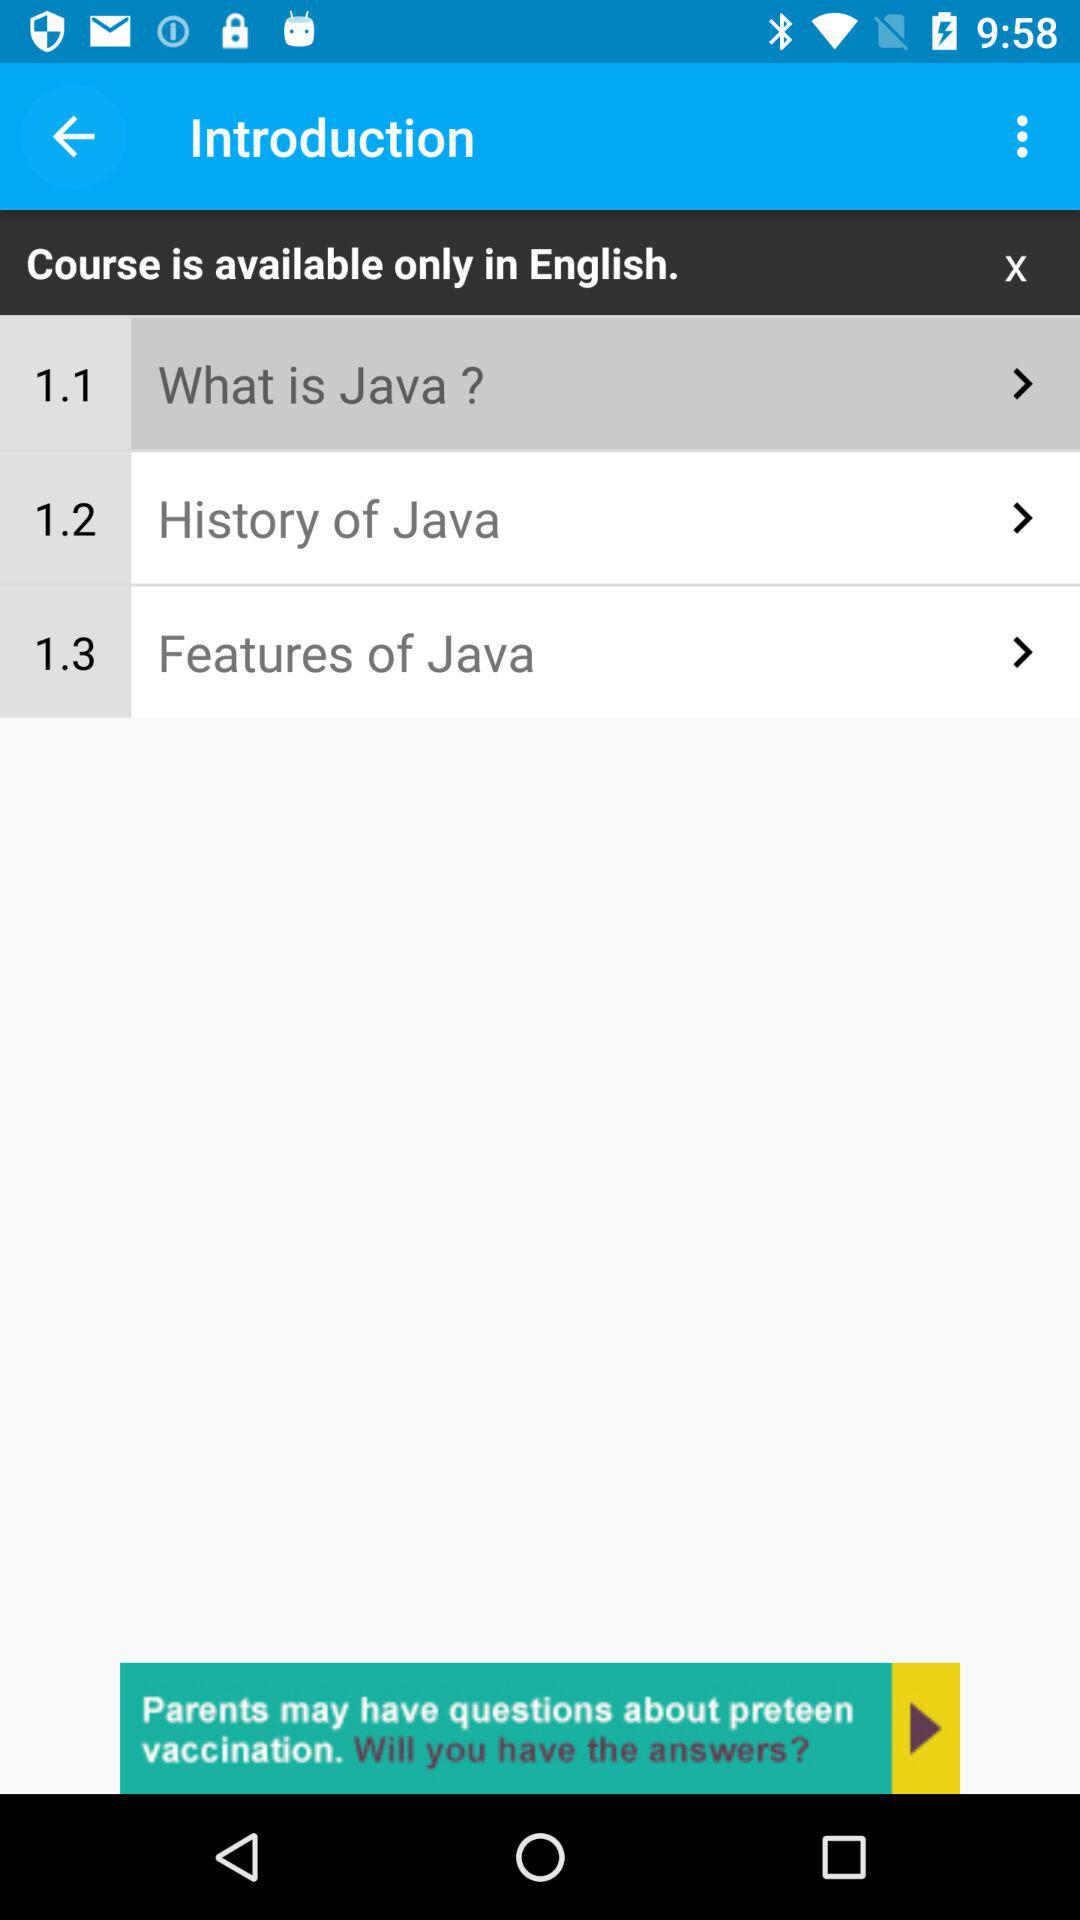Which option is selected? The selected option is "What is Java?". 